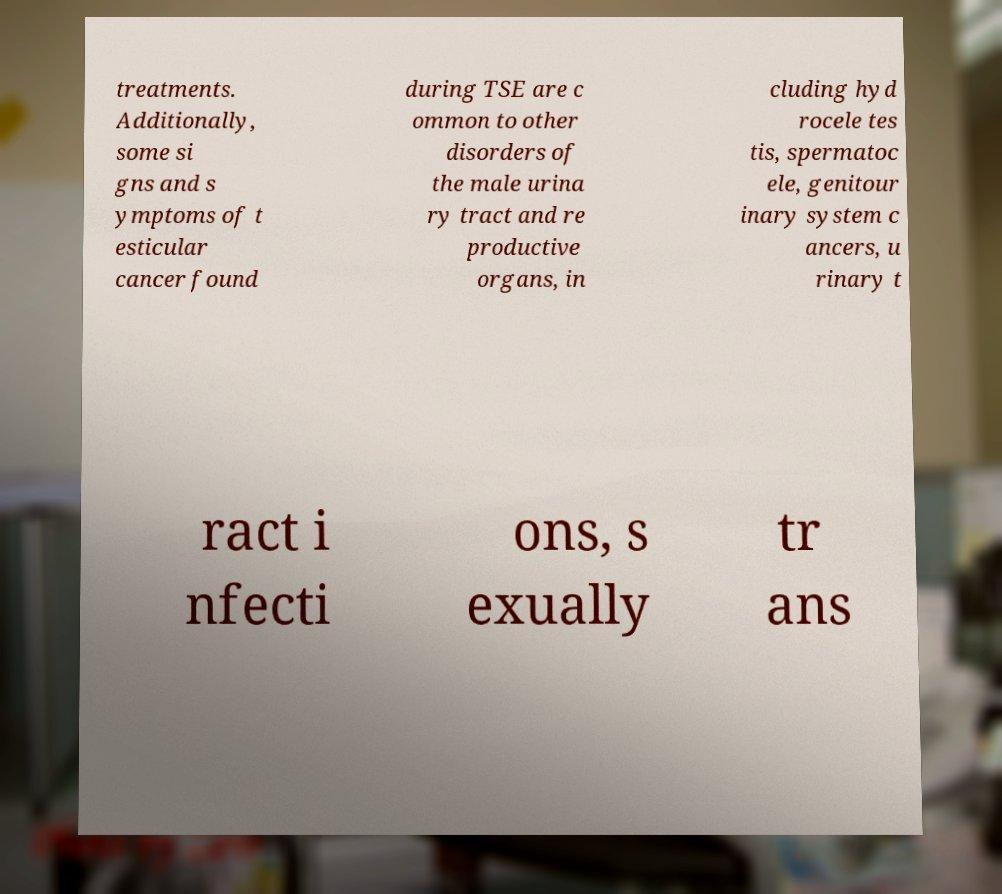Could you extract and type out the text from this image? treatments. Additionally, some si gns and s ymptoms of t esticular cancer found during TSE are c ommon to other disorders of the male urina ry tract and re productive organs, in cluding hyd rocele tes tis, spermatoc ele, genitour inary system c ancers, u rinary t ract i nfecti ons, s exually tr ans 